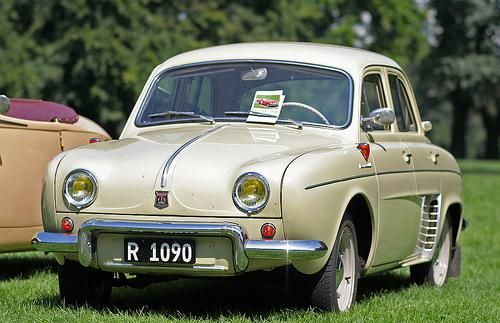Describe the surroundings of the car. The car is parked on well-manicured grass with what appears to be a park-like setting featuring lush green trees in the background, suggesting a serene or possibly a gathering like a car show. 